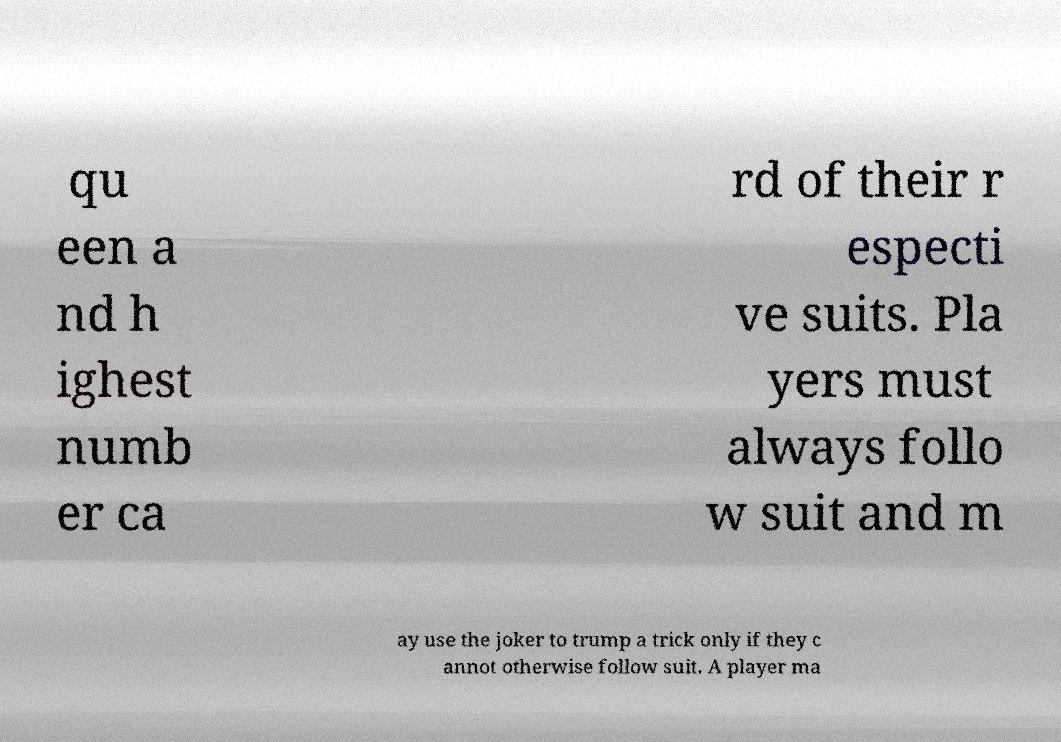Please identify and transcribe the text found in this image. qu een a nd h ighest numb er ca rd of their r especti ve suits. Pla yers must always follo w suit and m ay use the joker to trump a trick only if they c annot otherwise follow suit. A player ma 